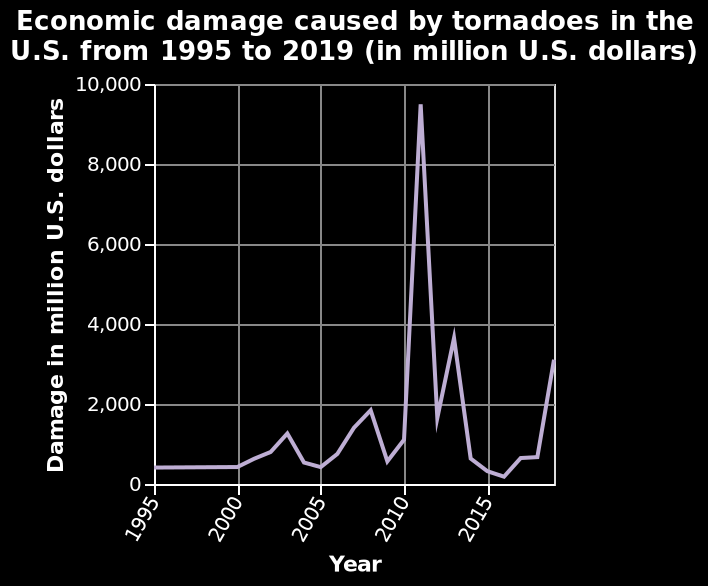<image>
Offer a thorough analysis of the image. The first fifteen years see the damage cost at the low rate of 2000 USD & under. 2010 - 2011 felt the full cost of the tornado damage, as it peaked just shy of 10,000 USD, before dramatically dropping back below the 2000 mark, and only rising again in 2013 and 2019 respectively. How much economic damage was caused during the peak year? The economic damage during the peak year amounted to $9 million dollars. 